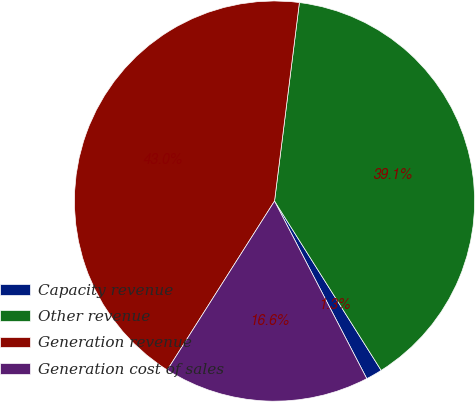<chart> <loc_0><loc_0><loc_500><loc_500><pie_chart><fcel>Capacity revenue<fcel>Other revenue<fcel>Generation revenue<fcel>Generation cost of sales<nl><fcel>1.32%<fcel>39.07%<fcel>42.98%<fcel>16.63%<nl></chart> 